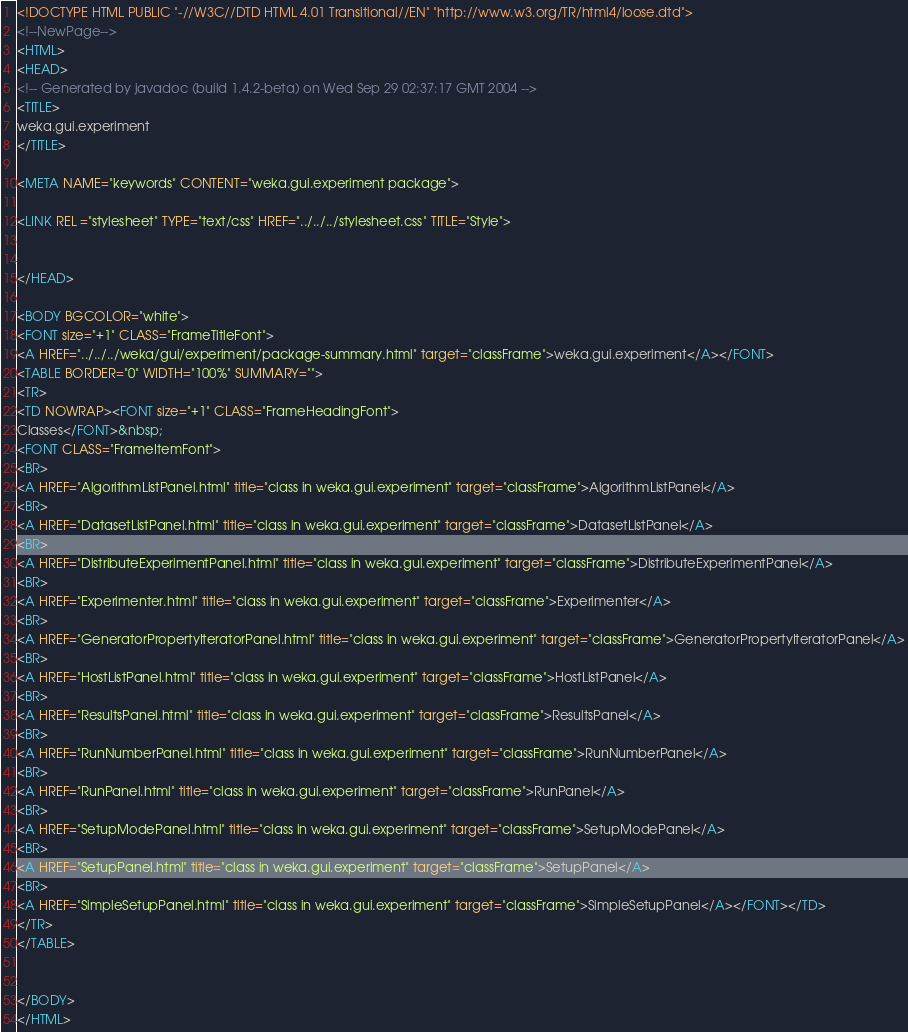Convert code to text. <code><loc_0><loc_0><loc_500><loc_500><_HTML_><!DOCTYPE HTML PUBLIC "-//W3C//DTD HTML 4.01 Transitional//EN" "http://www.w3.org/TR/html4/loose.dtd">
<!--NewPage-->
<HTML>
<HEAD>
<!-- Generated by javadoc (build 1.4.2-beta) on Wed Sep 29 02:37:17 GMT 2004 -->
<TITLE>
weka.gui.experiment
</TITLE>

<META NAME="keywords" CONTENT="weka.gui.experiment package">

<LINK REL ="stylesheet" TYPE="text/css" HREF="../../../stylesheet.css" TITLE="Style">


</HEAD>

<BODY BGCOLOR="white">
<FONT size="+1" CLASS="FrameTitleFont">
<A HREF="../../../weka/gui/experiment/package-summary.html" target="classFrame">weka.gui.experiment</A></FONT>
<TABLE BORDER="0" WIDTH="100%" SUMMARY="">
<TR>
<TD NOWRAP><FONT size="+1" CLASS="FrameHeadingFont">
Classes</FONT>&nbsp;
<FONT CLASS="FrameItemFont">
<BR>
<A HREF="AlgorithmListPanel.html" title="class in weka.gui.experiment" target="classFrame">AlgorithmListPanel</A>
<BR>
<A HREF="DatasetListPanel.html" title="class in weka.gui.experiment" target="classFrame">DatasetListPanel</A>
<BR>
<A HREF="DistributeExperimentPanel.html" title="class in weka.gui.experiment" target="classFrame">DistributeExperimentPanel</A>
<BR>
<A HREF="Experimenter.html" title="class in weka.gui.experiment" target="classFrame">Experimenter</A>
<BR>
<A HREF="GeneratorPropertyIteratorPanel.html" title="class in weka.gui.experiment" target="classFrame">GeneratorPropertyIteratorPanel</A>
<BR>
<A HREF="HostListPanel.html" title="class in weka.gui.experiment" target="classFrame">HostListPanel</A>
<BR>
<A HREF="ResultsPanel.html" title="class in weka.gui.experiment" target="classFrame">ResultsPanel</A>
<BR>
<A HREF="RunNumberPanel.html" title="class in weka.gui.experiment" target="classFrame">RunNumberPanel</A>
<BR>
<A HREF="RunPanel.html" title="class in weka.gui.experiment" target="classFrame">RunPanel</A>
<BR>
<A HREF="SetupModePanel.html" title="class in weka.gui.experiment" target="classFrame">SetupModePanel</A>
<BR>
<A HREF="SetupPanel.html" title="class in weka.gui.experiment" target="classFrame">SetupPanel</A>
<BR>
<A HREF="SimpleSetupPanel.html" title="class in weka.gui.experiment" target="classFrame">SimpleSetupPanel</A></FONT></TD>
</TR>
</TABLE>


</BODY>
</HTML>
</code> 